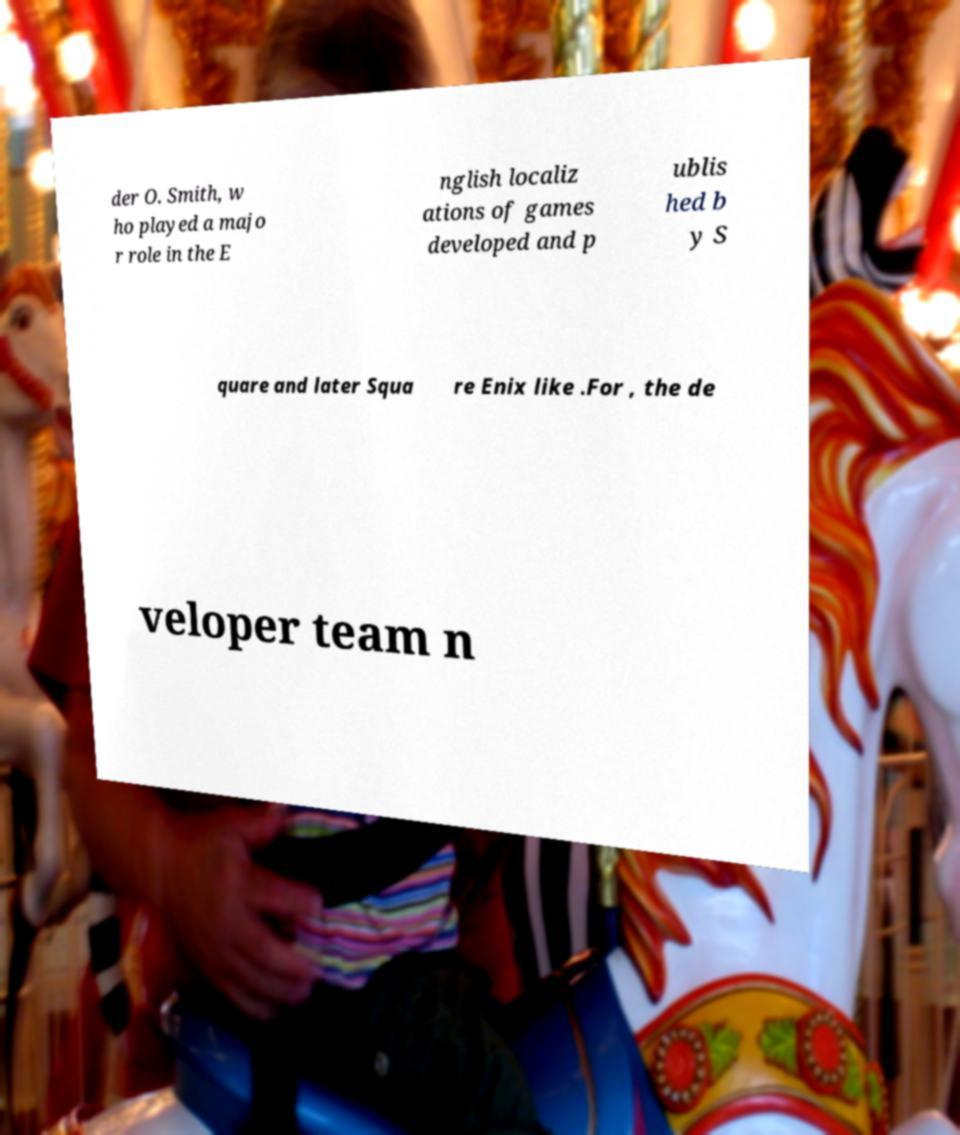For documentation purposes, I need the text within this image transcribed. Could you provide that? der O. Smith, w ho played a majo r role in the E nglish localiz ations of games developed and p ublis hed b y S quare and later Squa re Enix like .For , the de veloper team n 